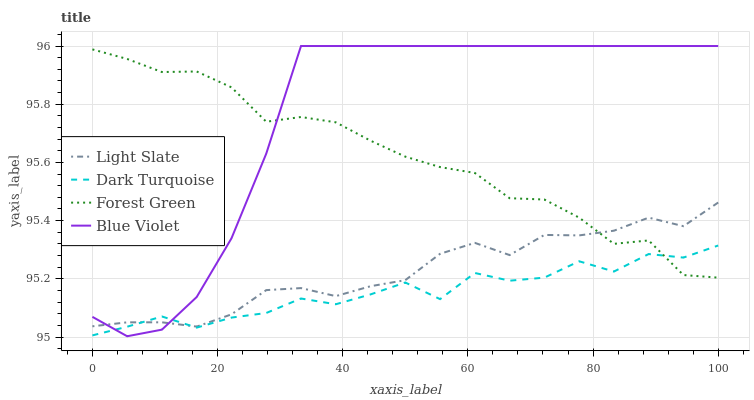Does Dark Turquoise have the minimum area under the curve?
Answer yes or no. Yes. Does Blue Violet have the maximum area under the curve?
Answer yes or no. Yes. Does Forest Green have the minimum area under the curve?
Answer yes or no. No. Does Forest Green have the maximum area under the curve?
Answer yes or no. No. Is Blue Violet the smoothest?
Answer yes or no. Yes. Is Dark Turquoise the roughest?
Answer yes or no. Yes. Is Forest Green the smoothest?
Answer yes or no. No. Is Forest Green the roughest?
Answer yes or no. No. Does Dark Turquoise have the lowest value?
Answer yes or no. No. Does Blue Violet have the highest value?
Answer yes or no. Yes. Does Forest Green have the highest value?
Answer yes or no. No. Does Blue Violet intersect Dark Turquoise?
Answer yes or no. Yes. Is Blue Violet less than Dark Turquoise?
Answer yes or no. No. Is Blue Violet greater than Dark Turquoise?
Answer yes or no. No. 